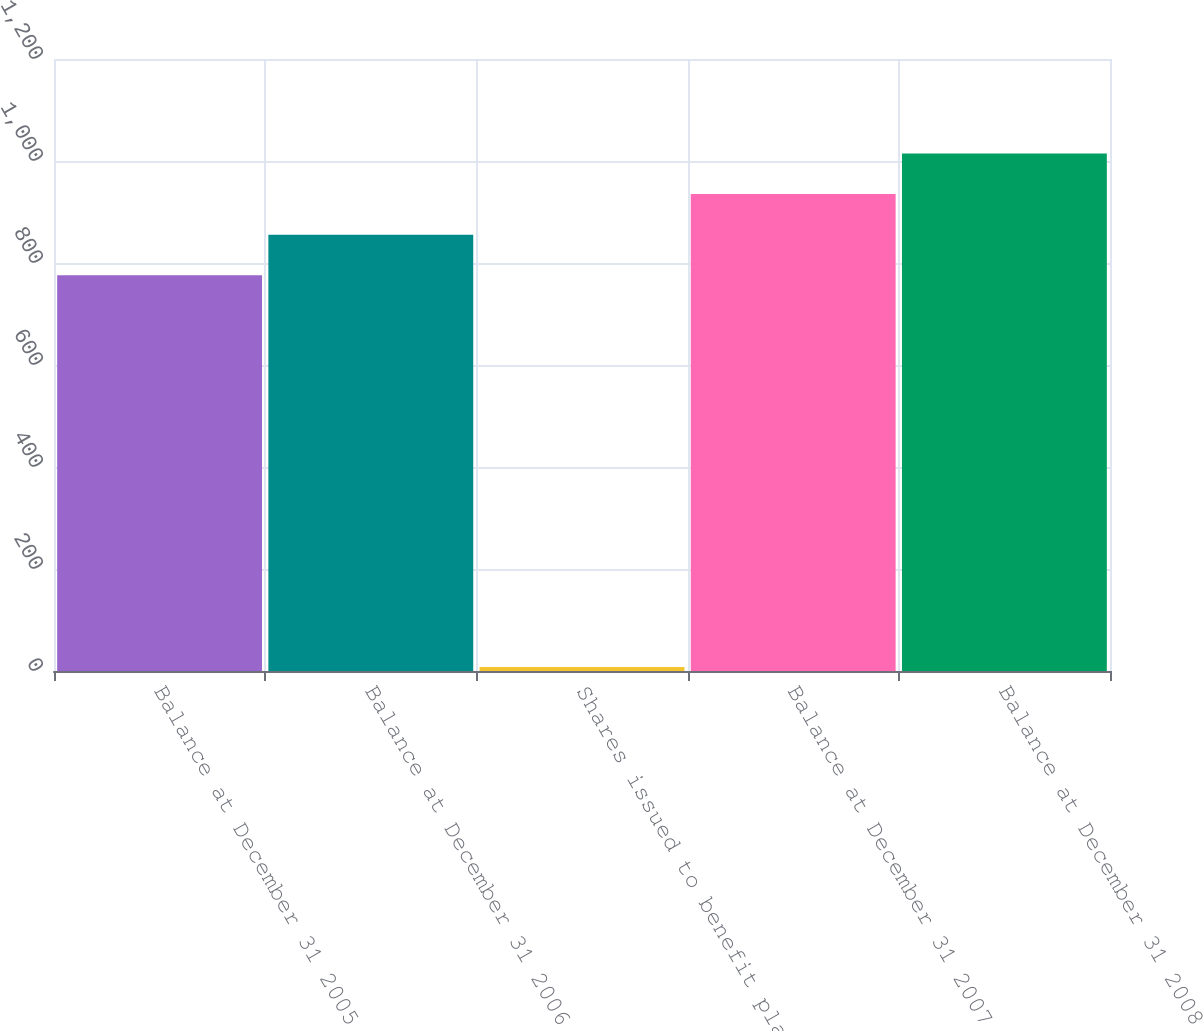<chart> <loc_0><loc_0><loc_500><loc_500><bar_chart><fcel>Balance at December 31 2005<fcel>Balance at December 31 2006<fcel>Shares issued to benefit plans<fcel>Balance at December 31 2007<fcel>Balance at December 31 2008<nl><fcel>776<fcel>855.6<fcel>8<fcel>935.2<fcel>1014.8<nl></chart> 